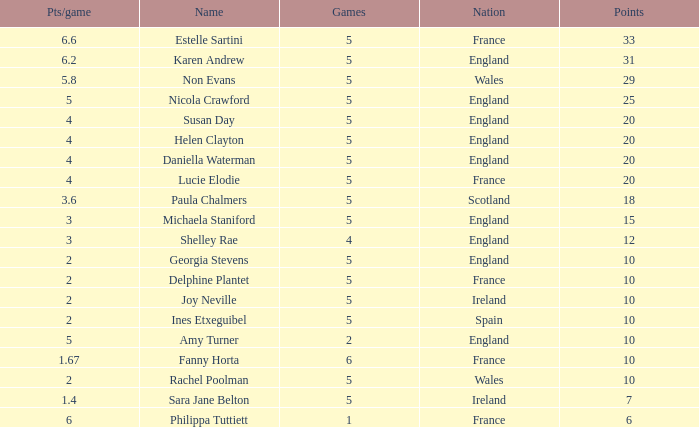Can you tell me the average Points that has a Pts/game larger than 4, and the Nation of england, and the Games smaller than 5? 10.0. 